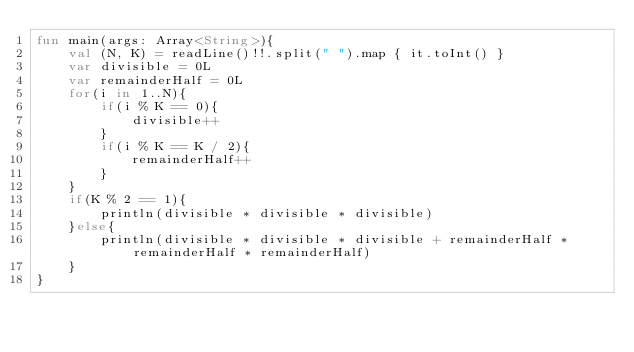<code> <loc_0><loc_0><loc_500><loc_500><_Kotlin_>fun main(args: Array<String>){
    val (N, K) = readLine()!!.split(" ").map { it.toInt() }
    var divisible = 0L
    var remainderHalf = 0L
    for(i in 1..N){
        if(i % K == 0){
            divisible++
        }
        if(i % K == K / 2){
            remainderHalf++
        }
    }
    if(K % 2 == 1){
        println(divisible * divisible * divisible)
    }else{
        println(divisible * divisible * divisible + remainderHalf * remainderHalf * remainderHalf)
    }
}</code> 